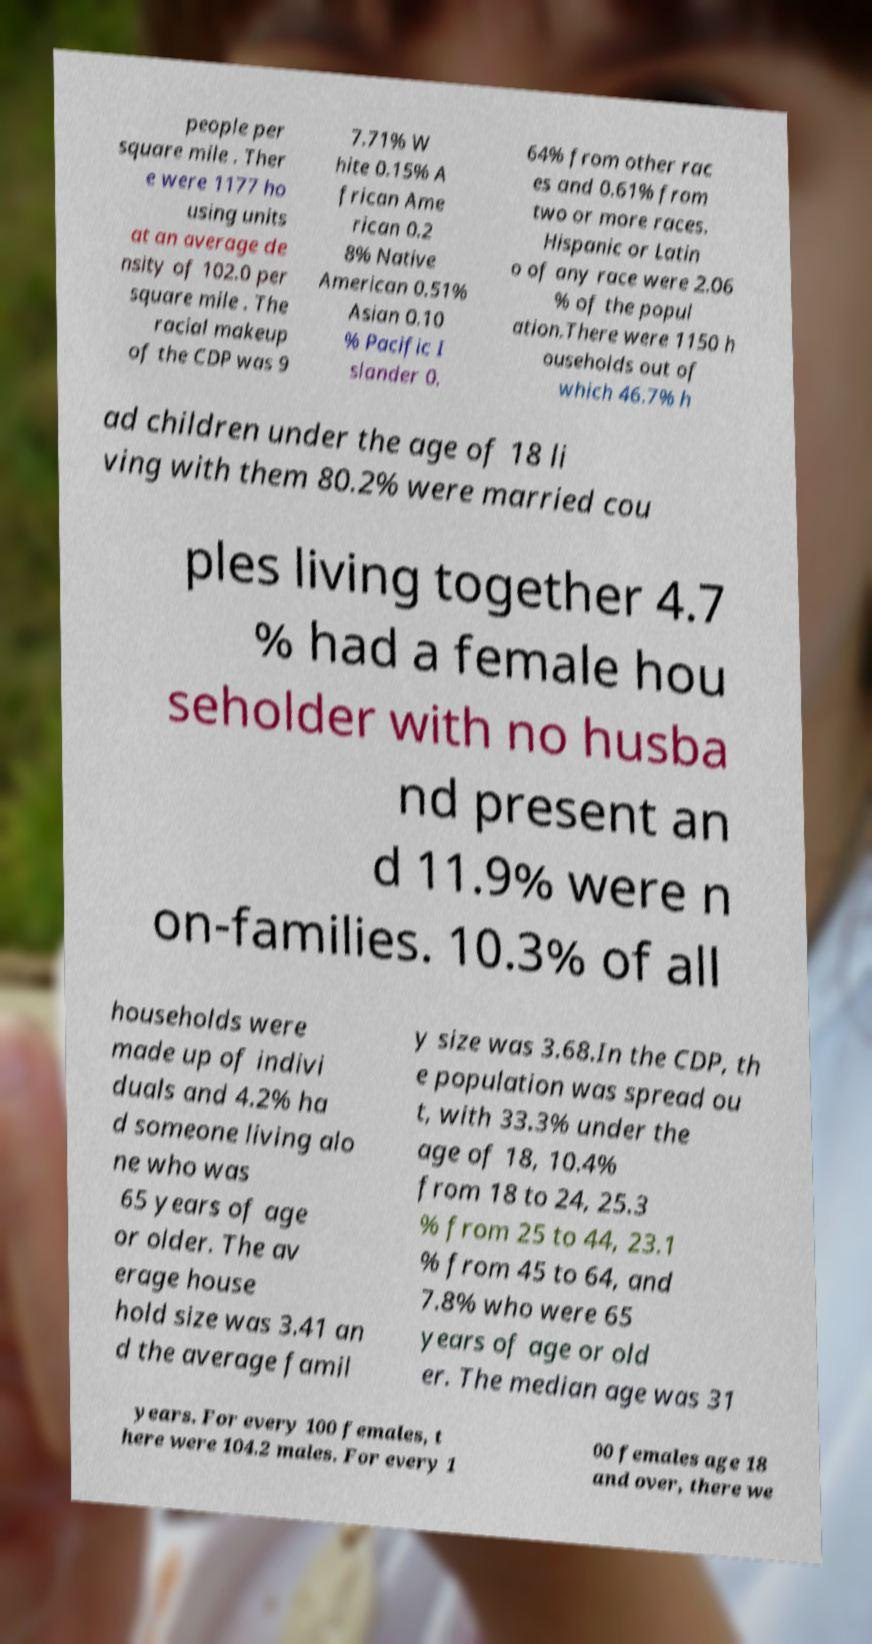Please read and relay the text visible in this image. What does it say? people per square mile . Ther e were 1177 ho using units at an average de nsity of 102.0 per square mile . The racial makeup of the CDP was 9 7.71% W hite 0.15% A frican Ame rican 0.2 8% Native American 0.51% Asian 0.10 % Pacific I slander 0. 64% from other rac es and 0.61% from two or more races. Hispanic or Latin o of any race were 2.06 % of the popul ation.There were 1150 h ouseholds out of which 46.7% h ad children under the age of 18 li ving with them 80.2% were married cou ples living together 4.7 % had a female hou seholder with no husba nd present an d 11.9% were n on-families. 10.3% of all households were made up of indivi duals and 4.2% ha d someone living alo ne who was 65 years of age or older. The av erage house hold size was 3.41 an d the average famil y size was 3.68.In the CDP, th e population was spread ou t, with 33.3% under the age of 18, 10.4% from 18 to 24, 25.3 % from 25 to 44, 23.1 % from 45 to 64, and 7.8% who were 65 years of age or old er. The median age was 31 years. For every 100 females, t here were 104.2 males. For every 1 00 females age 18 and over, there we 